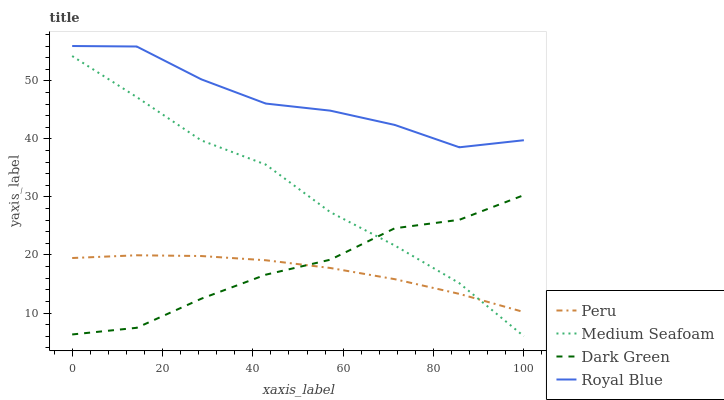Does Peru have the minimum area under the curve?
Answer yes or no. Yes. Does Royal Blue have the maximum area under the curve?
Answer yes or no. Yes. Does Medium Seafoam have the minimum area under the curve?
Answer yes or no. No. Does Medium Seafoam have the maximum area under the curve?
Answer yes or no. No. Is Peru the smoothest?
Answer yes or no. Yes. Is Royal Blue the roughest?
Answer yes or no. Yes. Is Medium Seafoam the smoothest?
Answer yes or no. No. Is Medium Seafoam the roughest?
Answer yes or no. No. Does Medium Seafoam have the lowest value?
Answer yes or no. Yes. Does Peru have the lowest value?
Answer yes or no. No. Does Royal Blue have the highest value?
Answer yes or no. Yes. Does Medium Seafoam have the highest value?
Answer yes or no. No. Is Dark Green less than Royal Blue?
Answer yes or no. Yes. Is Royal Blue greater than Medium Seafoam?
Answer yes or no. Yes. Does Dark Green intersect Peru?
Answer yes or no. Yes. Is Dark Green less than Peru?
Answer yes or no. No. Is Dark Green greater than Peru?
Answer yes or no. No. Does Dark Green intersect Royal Blue?
Answer yes or no. No. 